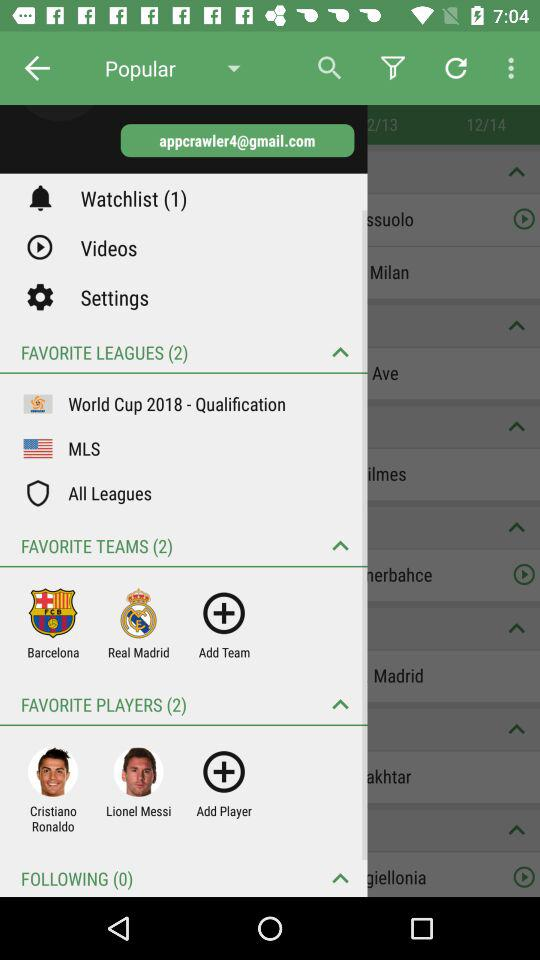How many more favorite players do I have than followings?
Answer the question using a single word or phrase. 2 